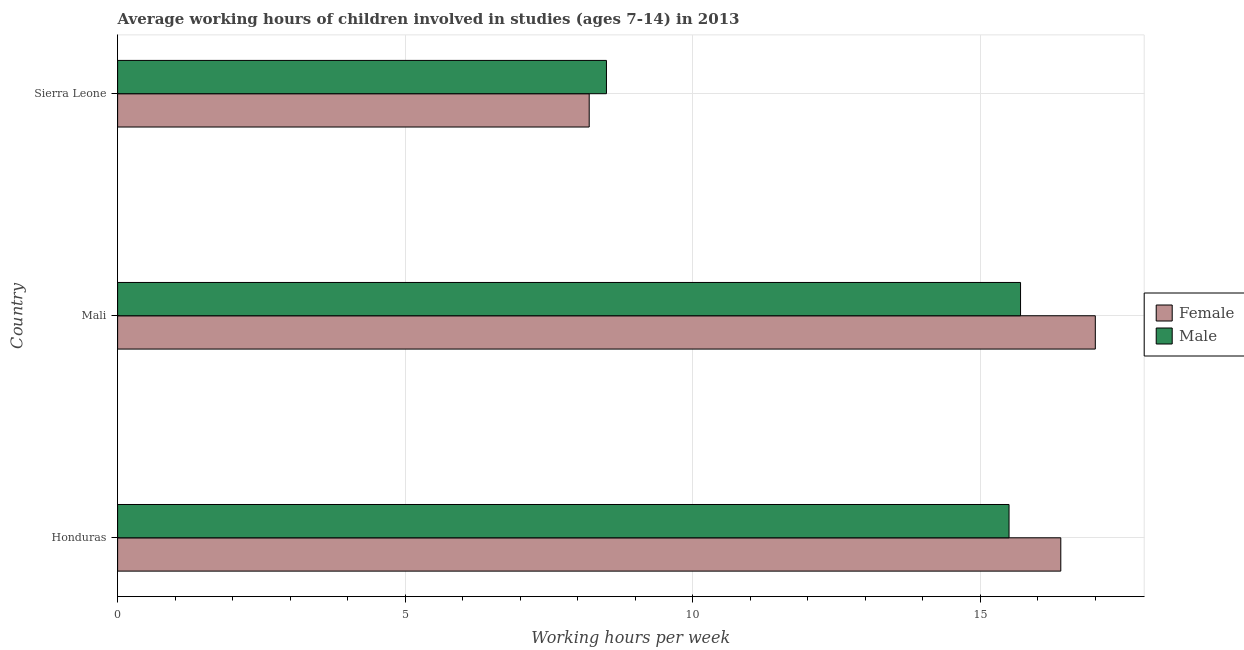How many bars are there on the 1st tick from the top?
Your answer should be very brief. 2. How many bars are there on the 3rd tick from the bottom?
Make the answer very short. 2. What is the label of the 3rd group of bars from the top?
Your answer should be very brief. Honduras. In how many cases, is the number of bars for a given country not equal to the number of legend labels?
Make the answer very short. 0. What is the average working hour of female children in Mali?
Make the answer very short. 17. Across all countries, what is the maximum average working hour of male children?
Give a very brief answer. 15.7. In which country was the average working hour of male children maximum?
Ensure brevity in your answer.  Mali. In which country was the average working hour of male children minimum?
Ensure brevity in your answer.  Sierra Leone. What is the total average working hour of male children in the graph?
Provide a short and direct response. 39.7. What is the difference between the average working hour of male children in Mali and that in Sierra Leone?
Offer a terse response. 7.2. What is the difference between the average working hour of female children in Mali and the average working hour of male children in Honduras?
Your answer should be very brief. 1.5. What is the average average working hour of female children per country?
Give a very brief answer. 13.87. In how many countries, is the average working hour of female children greater than 6 hours?
Make the answer very short. 3. What is the ratio of the average working hour of male children in Honduras to that in Sierra Leone?
Provide a short and direct response. 1.82. Is the difference between the average working hour of female children in Honduras and Mali greater than the difference between the average working hour of male children in Honduras and Mali?
Your answer should be very brief. No. What is the difference between the highest and the lowest average working hour of male children?
Provide a short and direct response. 7.2. In how many countries, is the average working hour of male children greater than the average average working hour of male children taken over all countries?
Your answer should be compact. 2. Is the sum of the average working hour of female children in Honduras and Mali greater than the maximum average working hour of male children across all countries?
Give a very brief answer. Yes. What does the 1st bar from the top in Sierra Leone represents?
Provide a succinct answer. Male. How many bars are there?
Provide a short and direct response. 6. Are all the bars in the graph horizontal?
Make the answer very short. Yes. How many countries are there in the graph?
Provide a succinct answer. 3. What is the difference between two consecutive major ticks on the X-axis?
Offer a very short reply. 5. Does the graph contain any zero values?
Give a very brief answer. No. Where does the legend appear in the graph?
Offer a terse response. Center right. How many legend labels are there?
Your answer should be very brief. 2. How are the legend labels stacked?
Provide a succinct answer. Vertical. What is the title of the graph?
Offer a terse response. Average working hours of children involved in studies (ages 7-14) in 2013. What is the label or title of the X-axis?
Keep it short and to the point. Working hours per week. What is the Working hours per week of Female in Honduras?
Your answer should be compact. 16.4. What is the Working hours per week of Male in Honduras?
Ensure brevity in your answer.  15.5. What is the Working hours per week in Female in Mali?
Your answer should be compact. 17. What is the Working hours per week of Male in Mali?
Make the answer very short. 15.7. Across all countries, what is the maximum Working hours per week of Male?
Your answer should be compact. 15.7. Across all countries, what is the minimum Working hours per week in Female?
Make the answer very short. 8.2. What is the total Working hours per week of Female in the graph?
Provide a short and direct response. 41.6. What is the total Working hours per week in Male in the graph?
Your answer should be compact. 39.7. What is the difference between the Working hours per week in Female in Honduras and that in Sierra Leone?
Offer a terse response. 8.2. What is the difference between the Working hours per week of Male in Mali and that in Sierra Leone?
Keep it short and to the point. 7.2. What is the difference between the Working hours per week in Female in Honduras and the Working hours per week in Male in Mali?
Give a very brief answer. 0.7. What is the difference between the Working hours per week in Female in Honduras and the Working hours per week in Male in Sierra Leone?
Your answer should be very brief. 7.9. What is the average Working hours per week in Female per country?
Give a very brief answer. 13.87. What is the average Working hours per week in Male per country?
Provide a succinct answer. 13.23. What is the difference between the Working hours per week in Female and Working hours per week in Male in Mali?
Offer a terse response. 1.3. What is the ratio of the Working hours per week of Female in Honduras to that in Mali?
Your answer should be compact. 0.96. What is the ratio of the Working hours per week of Male in Honduras to that in Mali?
Offer a very short reply. 0.99. What is the ratio of the Working hours per week in Female in Honduras to that in Sierra Leone?
Ensure brevity in your answer.  2. What is the ratio of the Working hours per week in Male in Honduras to that in Sierra Leone?
Make the answer very short. 1.82. What is the ratio of the Working hours per week in Female in Mali to that in Sierra Leone?
Offer a very short reply. 2.07. What is the ratio of the Working hours per week in Male in Mali to that in Sierra Leone?
Provide a succinct answer. 1.85. What is the difference between the highest and the second highest Working hours per week of Male?
Offer a very short reply. 0.2. 